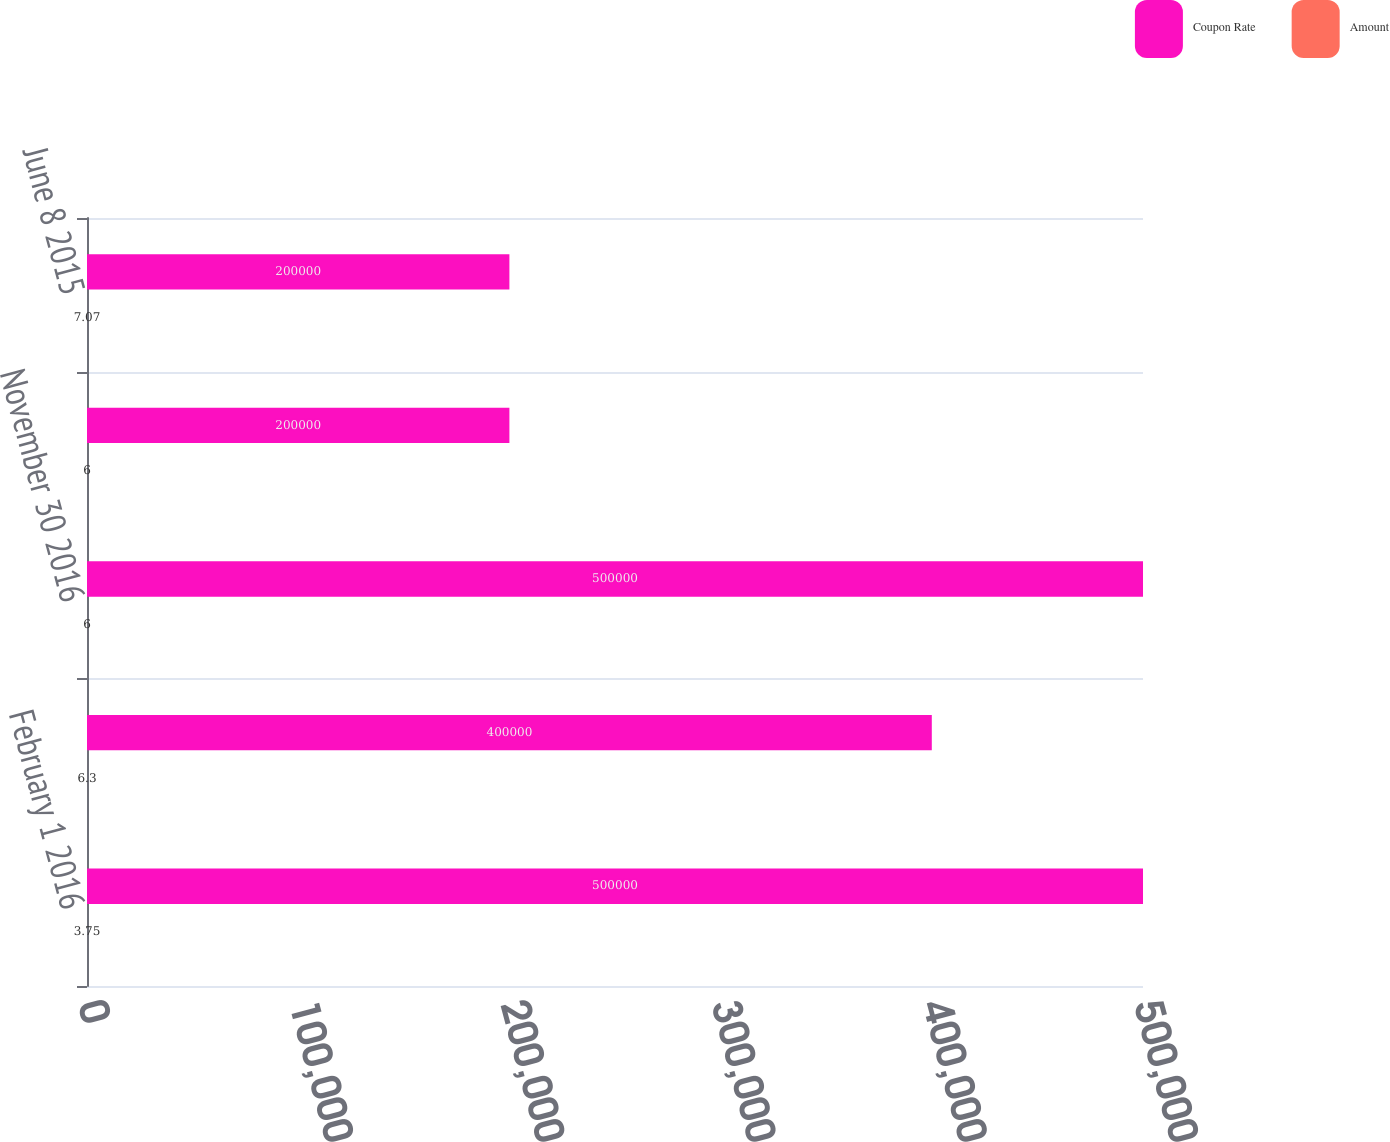Convert chart to OTSL. <chart><loc_0><loc_0><loc_500><loc_500><stacked_bar_chart><ecel><fcel>February 1 2016<fcel>September 15 2016<fcel>November 30 2016<fcel>March 1 2015<fcel>June 8 2015<nl><fcel>Coupon Rate<fcel>500000<fcel>400000<fcel>500000<fcel>200000<fcel>200000<nl><fcel>Amount<fcel>3.75<fcel>6.3<fcel>6<fcel>6<fcel>7.07<nl></chart> 